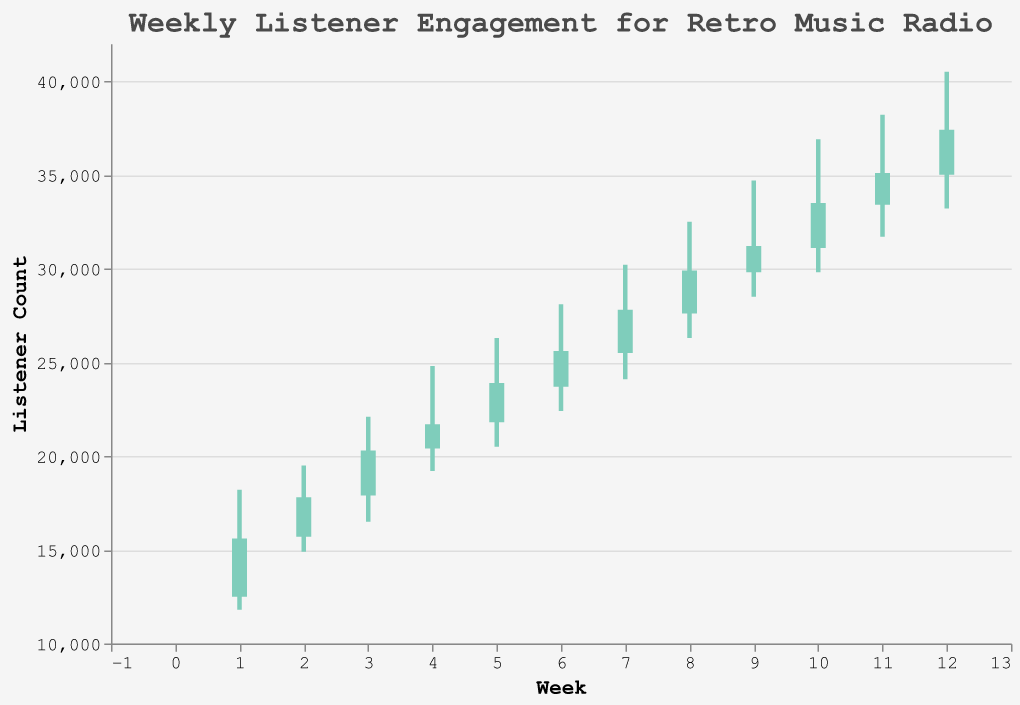What is the highest listener count for any week? The chart indicates the peak listener counts for each week, identified by the 'High' values. The highest listener count is achieved in Week 12, with a peak of 40,500 listeners.
Answer: 40,500 What was the listener count at the start of Week 5? The 'Open' value for Week 5 shows the listener count at the beginning of the week. For Week 5, the opening listener count is 21,800.
Answer: 21,800 In which week did the listener count close the highest? The 'Close' value indicates the listener count at the end of each week. The highest closing listener count is in Week 12, with a count of 37,400.
Answer: Week 12 How many weeks experienced a drop in listener count from open to close? The bar colors differentiate weeks where the 'Open' is lower (green) vs. higher (red) compared to the 'Close'. The red bars represent weeks with a drop. Counting the red bars yields 3 weeks (Weeks 1, 4, and 11).
Answer: 3 weeks Identify the week with the lowest minimum listener count. The 'Low' values represent the minimum listener counts each week. The lowest value is 11,800 in Week 1.
Answer: Week 1 What is the total increase in the closing listener count from Week 1 to Week 12? To find the total increase, subtract the 'Close' value of Week 1 from that of Week 12: 37,400 - 15,600 = 21,800.
Answer: 21,800 Which week had the smallest range in listener counts from the lowest to highest point? The range is calculated as High - Low for each week. Week 1 has the smallest range with 18,200 - 11,800 = 6,400.
Answer: Week 1 Compare Week 6 and Week 7: Which had a higher closing listener count? The 'Close' values for Weeks 6 and 7 are 25,600 and 27,800, respectively. Week 7 closed higher.
Answer: Week 7 What was the peak listener count in Week 9, and how does it compare with Week 10? The peak (High) values are 34,700 for Week 9 and 36,900 for Week 10. Week 10 has a higher peak.
Answer: Week 10 By how much did the listener count increase from the open to the close in Week 3? Subtract the 'Open' value from the 'Close' value for Week 3: 20,300 - 17,900= 2,400.
Answer: 2,400 